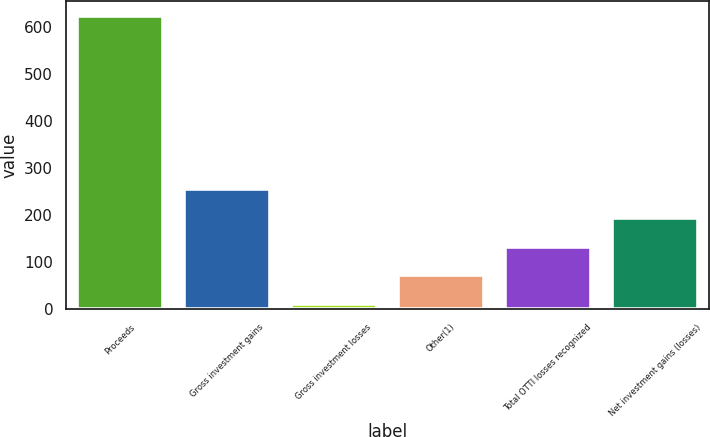Convert chart to OTSL. <chart><loc_0><loc_0><loc_500><loc_500><bar_chart><fcel>Proceeds<fcel>Gross investment gains<fcel>Gross investment losses<fcel>Other(1)<fcel>Total OTTI losses recognized<fcel>Net investment gains (losses)<nl><fcel>623<fcel>255.8<fcel>11<fcel>72.2<fcel>133.4<fcel>194.6<nl></chart> 